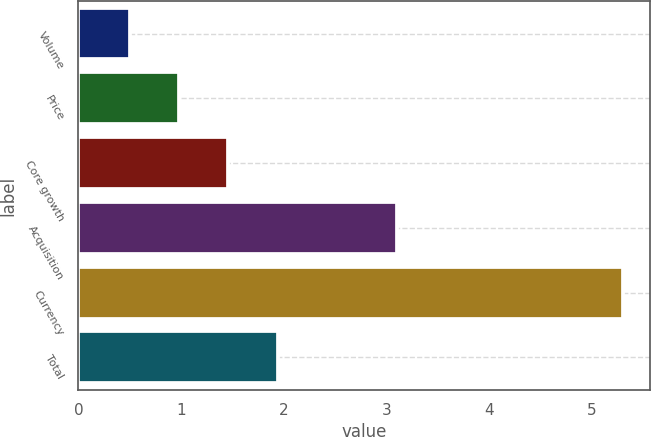<chart> <loc_0><loc_0><loc_500><loc_500><bar_chart><fcel>Volume<fcel>Price<fcel>Core growth<fcel>Acquisition<fcel>Currency<fcel>Total<nl><fcel>0.5<fcel>0.98<fcel>1.46<fcel>3.1<fcel>5.3<fcel>1.94<nl></chart> 